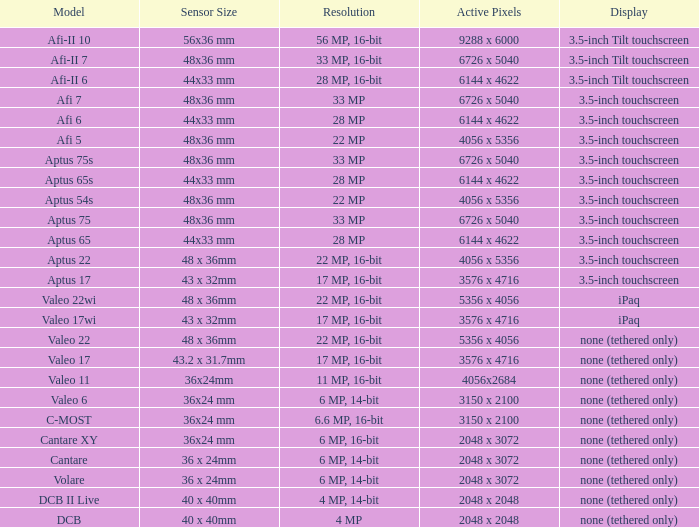Which model has a sensor sized 48x36 mm, pixels of 6726 x 5040, and a 33 mp resolution? Afi 7, Aptus 75s, Aptus 75. Could you help me parse every detail presented in this table? {'header': ['Model', 'Sensor Size', 'Resolution', 'Active Pixels', 'Display'], 'rows': [['Afi-II 10', '56x36 mm', '56 MP, 16-bit', '9288 x 6000', '3.5-inch Tilt touchscreen'], ['Afi-II 7', '48x36 mm', '33 MP, 16-bit', '6726 x 5040', '3.5-inch Tilt touchscreen'], ['Afi-II 6', '44x33 mm', '28 MP, 16-bit', '6144 x 4622', '3.5-inch Tilt touchscreen'], ['Afi 7', '48x36 mm', '33 MP', '6726 x 5040', '3.5-inch touchscreen'], ['Afi 6', '44x33 mm', '28 MP', '6144 x 4622', '3.5-inch touchscreen'], ['Afi 5', '48x36 mm', '22 MP', '4056 x 5356', '3.5-inch touchscreen'], ['Aptus 75s', '48x36 mm', '33 MP', '6726 x 5040', '3.5-inch touchscreen'], ['Aptus 65s', '44x33 mm', '28 MP', '6144 x 4622', '3.5-inch touchscreen'], ['Aptus 54s', '48x36 mm', '22 MP', '4056 x 5356', '3.5-inch touchscreen'], ['Aptus 75', '48x36 mm', '33 MP', '6726 x 5040', '3.5-inch touchscreen'], ['Aptus 65', '44x33 mm', '28 MP', '6144 x 4622', '3.5-inch touchscreen'], ['Aptus 22', '48 x 36mm', '22 MP, 16-bit', '4056 x 5356', '3.5-inch touchscreen'], ['Aptus 17', '43 x 32mm', '17 MP, 16-bit', '3576 x 4716', '3.5-inch touchscreen'], ['Valeo 22wi', '48 x 36mm', '22 MP, 16-bit', '5356 x 4056', 'iPaq'], ['Valeo 17wi', '43 x 32mm', '17 MP, 16-bit', '3576 x 4716', 'iPaq'], ['Valeo 22', '48 x 36mm', '22 MP, 16-bit', '5356 x 4056', 'none (tethered only)'], ['Valeo 17', '43.2 x 31.7mm', '17 MP, 16-bit', '3576 x 4716', 'none (tethered only)'], ['Valeo 11', '36x24mm', '11 MP, 16-bit', '4056x2684', 'none (tethered only)'], ['Valeo 6', '36x24 mm', '6 MP, 14-bit', '3150 x 2100', 'none (tethered only)'], ['C-MOST', '36x24 mm', '6.6 MP, 16-bit', '3150 x 2100', 'none (tethered only)'], ['Cantare XY', '36x24 mm', '6 MP, 16-bit', '2048 x 3072', 'none (tethered only)'], ['Cantare', '36 x 24mm', '6 MP, 14-bit', '2048 x 3072', 'none (tethered only)'], ['Volare', '36 x 24mm', '6 MP, 14-bit', '2048 x 3072', 'none (tethered only)'], ['DCB II Live', '40 x 40mm', '4 MP, 14-bit', '2048 x 2048', 'none (tethered only)'], ['DCB', '40 x 40mm', '4 MP', '2048 x 2048', 'none (tethered only)']]} 